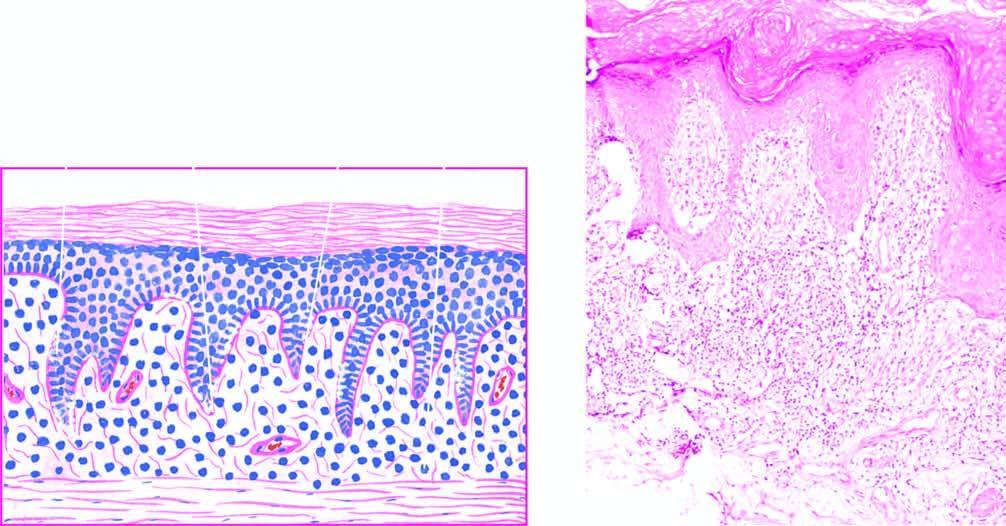what shows a band-like mononuclear infiltrate with a sharply-demarcated lower border?
Answer the question using a single word or phrase. Upper dermis 